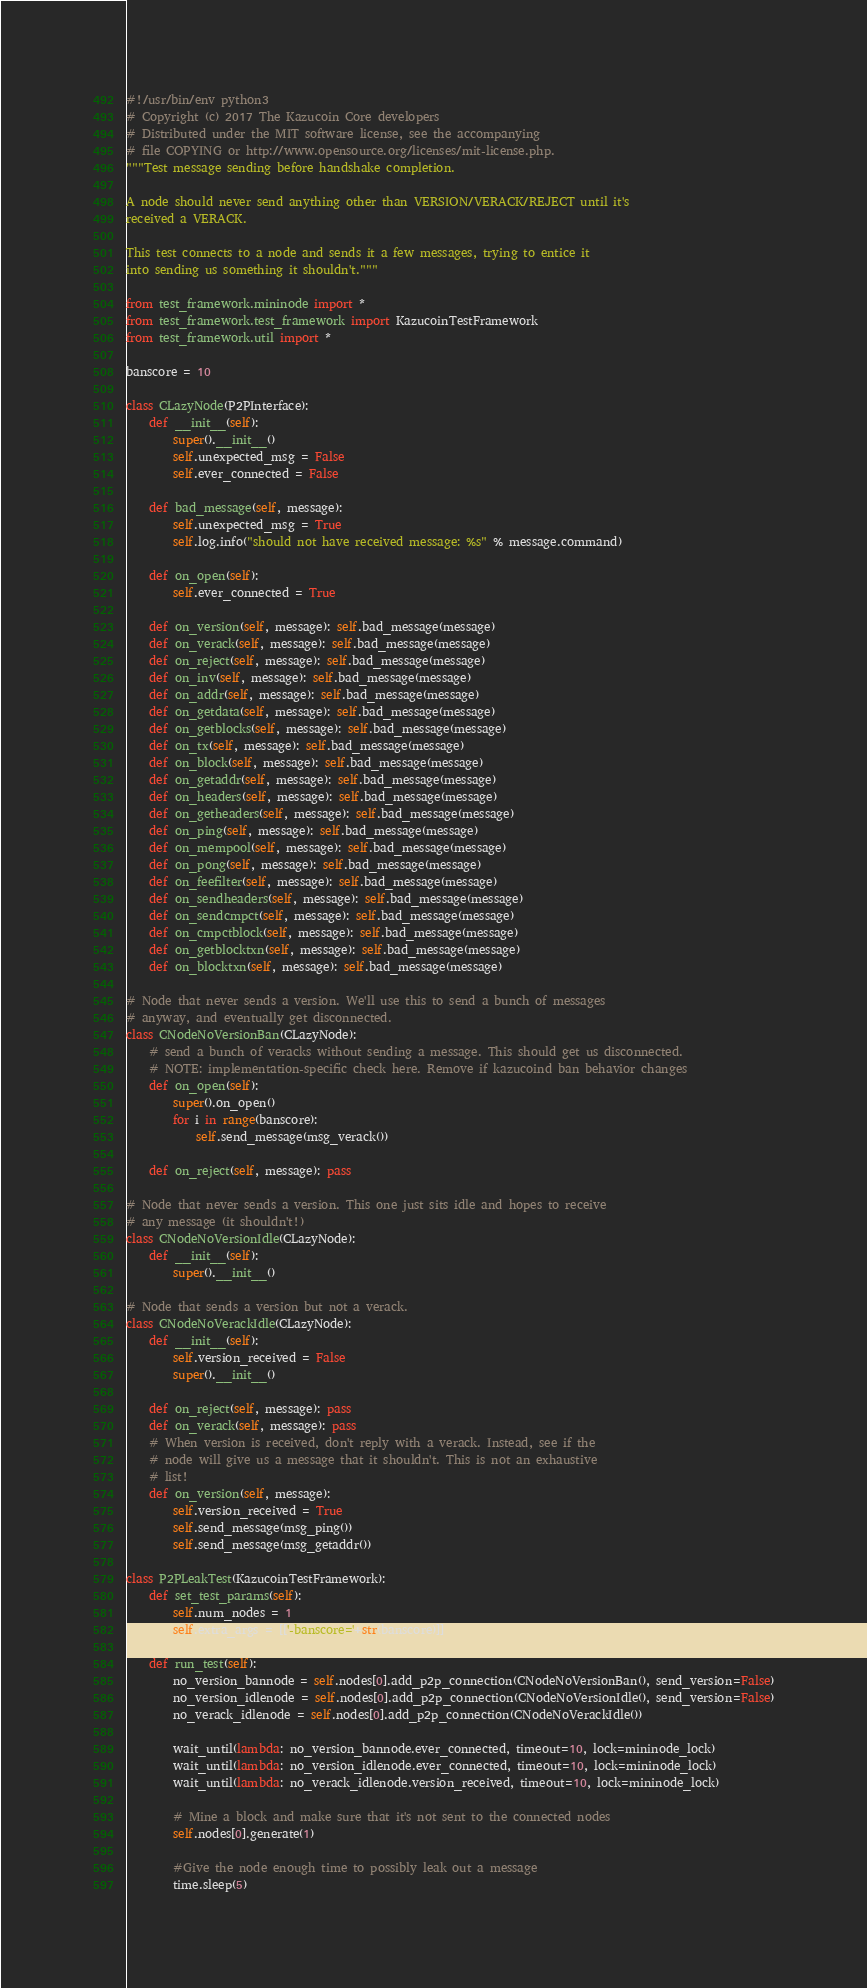<code> <loc_0><loc_0><loc_500><loc_500><_Python_>#!/usr/bin/env python3
# Copyright (c) 2017 The Kazucoin Core developers
# Distributed under the MIT software license, see the accompanying
# file COPYING or http://www.opensource.org/licenses/mit-license.php.
"""Test message sending before handshake completion.

A node should never send anything other than VERSION/VERACK/REJECT until it's
received a VERACK.

This test connects to a node and sends it a few messages, trying to entice it
into sending us something it shouldn't."""

from test_framework.mininode import *
from test_framework.test_framework import KazucoinTestFramework
from test_framework.util import *

banscore = 10

class CLazyNode(P2PInterface):
    def __init__(self):
        super().__init__()
        self.unexpected_msg = False
        self.ever_connected = False

    def bad_message(self, message):
        self.unexpected_msg = True
        self.log.info("should not have received message: %s" % message.command)

    def on_open(self):
        self.ever_connected = True

    def on_version(self, message): self.bad_message(message)
    def on_verack(self, message): self.bad_message(message)
    def on_reject(self, message): self.bad_message(message)
    def on_inv(self, message): self.bad_message(message)
    def on_addr(self, message): self.bad_message(message)
    def on_getdata(self, message): self.bad_message(message)
    def on_getblocks(self, message): self.bad_message(message)
    def on_tx(self, message): self.bad_message(message)
    def on_block(self, message): self.bad_message(message)
    def on_getaddr(self, message): self.bad_message(message)
    def on_headers(self, message): self.bad_message(message)
    def on_getheaders(self, message): self.bad_message(message)
    def on_ping(self, message): self.bad_message(message)
    def on_mempool(self, message): self.bad_message(message)
    def on_pong(self, message): self.bad_message(message)
    def on_feefilter(self, message): self.bad_message(message)
    def on_sendheaders(self, message): self.bad_message(message)
    def on_sendcmpct(self, message): self.bad_message(message)
    def on_cmpctblock(self, message): self.bad_message(message)
    def on_getblocktxn(self, message): self.bad_message(message)
    def on_blocktxn(self, message): self.bad_message(message)

# Node that never sends a version. We'll use this to send a bunch of messages
# anyway, and eventually get disconnected.
class CNodeNoVersionBan(CLazyNode):
    # send a bunch of veracks without sending a message. This should get us disconnected.
    # NOTE: implementation-specific check here. Remove if kazucoind ban behavior changes
    def on_open(self):
        super().on_open()
        for i in range(banscore):
            self.send_message(msg_verack())

    def on_reject(self, message): pass

# Node that never sends a version. This one just sits idle and hopes to receive
# any message (it shouldn't!)
class CNodeNoVersionIdle(CLazyNode):
    def __init__(self):
        super().__init__()

# Node that sends a version but not a verack.
class CNodeNoVerackIdle(CLazyNode):
    def __init__(self):
        self.version_received = False
        super().__init__()

    def on_reject(self, message): pass
    def on_verack(self, message): pass
    # When version is received, don't reply with a verack. Instead, see if the
    # node will give us a message that it shouldn't. This is not an exhaustive
    # list!
    def on_version(self, message):
        self.version_received = True
        self.send_message(msg_ping())
        self.send_message(msg_getaddr())

class P2PLeakTest(KazucoinTestFramework):
    def set_test_params(self):
        self.num_nodes = 1
        self.extra_args = [['-banscore='+str(banscore)]]

    def run_test(self):
        no_version_bannode = self.nodes[0].add_p2p_connection(CNodeNoVersionBan(), send_version=False)
        no_version_idlenode = self.nodes[0].add_p2p_connection(CNodeNoVersionIdle(), send_version=False)
        no_verack_idlenode = self.nodes[0].add_p2p_connection(CNodeNoVerackIdle())

        wait_until(lambda: no_version_bannode.ever_connected, timeout=10, lock=mininode_lock)
        wait_until(lambda: no_version_idlenode.ever_connected, timeout=10, lock=mininode_lock)
        wait_until(lambda: no_verack_idlenode.version_received, timeout=10, lock=mininode_lock)

        # Mine a block and make sure that it's not sent to the connected nodes
        self.nodes[0].generate(1)

        #Give the node enough time to possibly leak out a message
        time.sleep(5)
</code> 